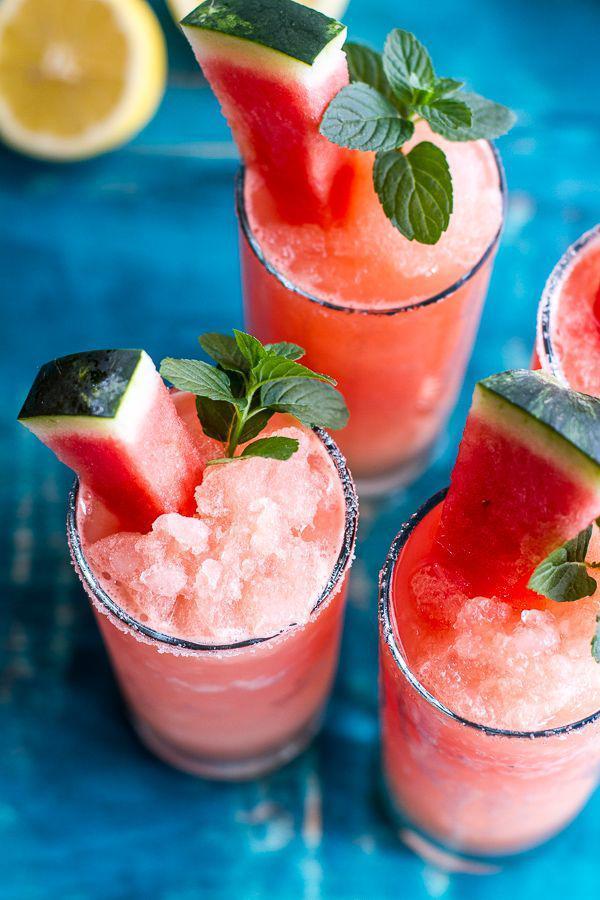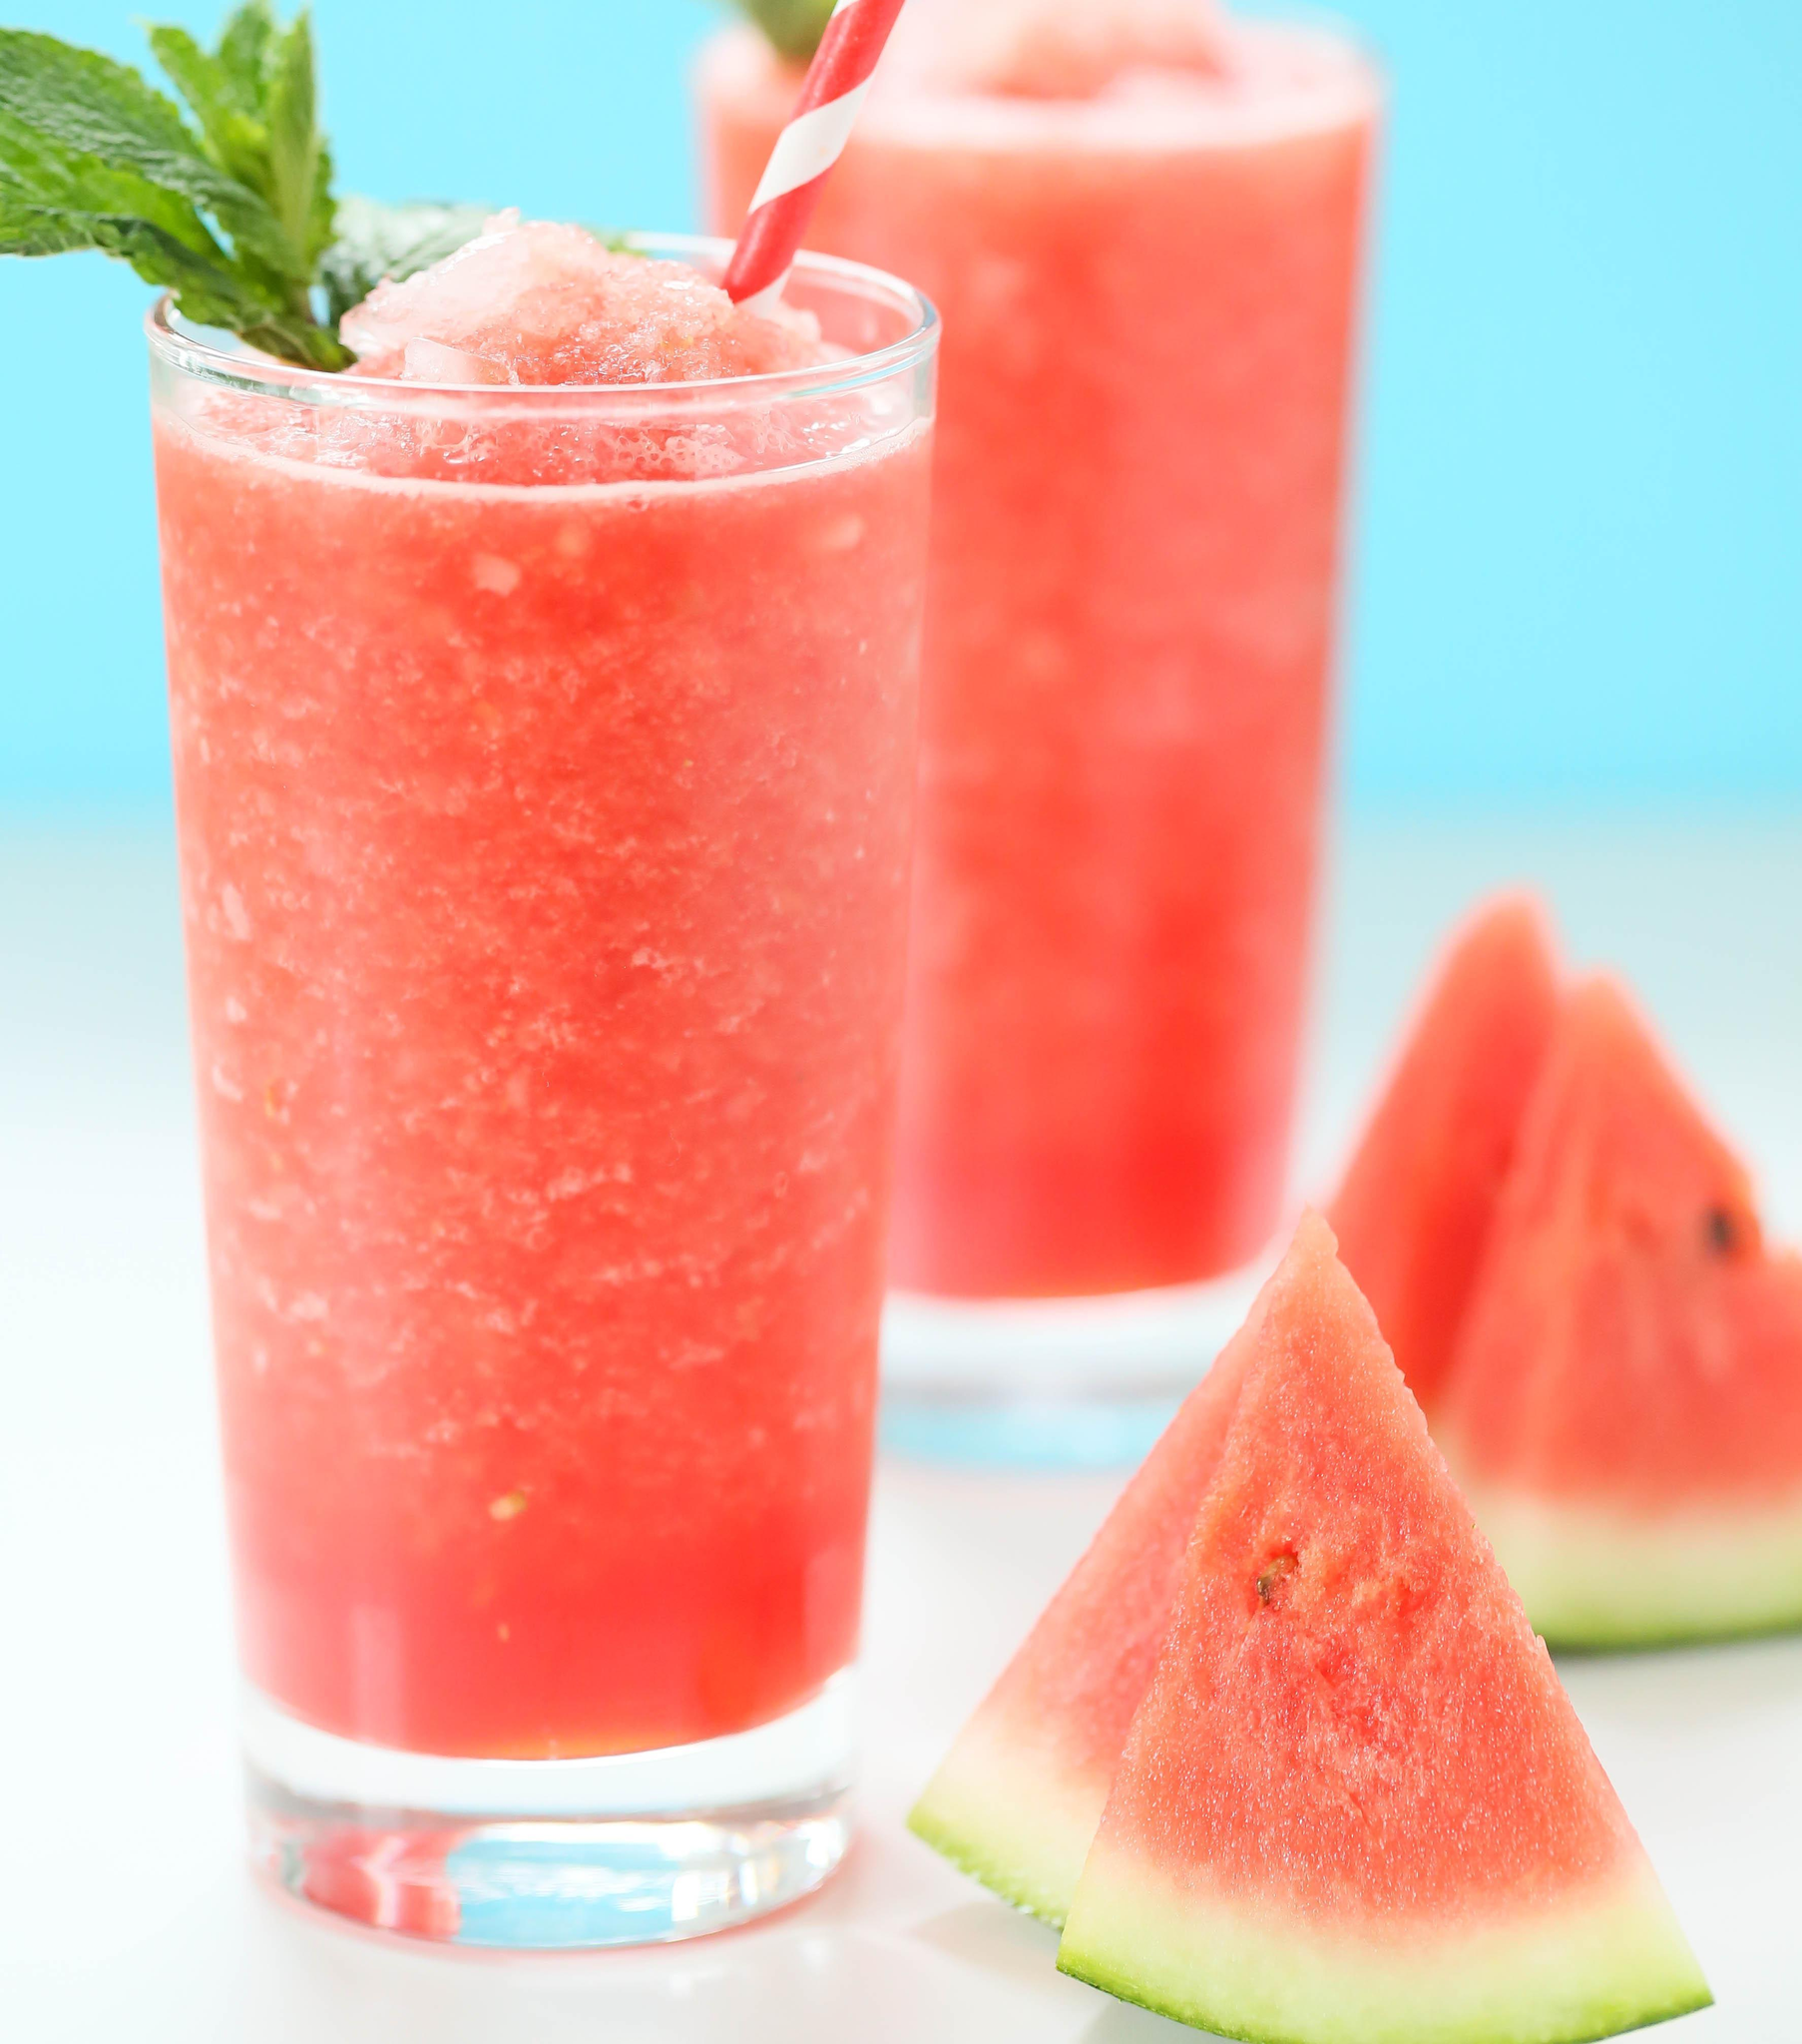The first image is the image on the left, the second image is the image on the right. Given the left and right images, does the statement "There are no more than 5 full drink glasses." hold true? Answer yes or no. No. The first image is the image on the left, the second image is the image on the right. Analyze the images presented: Is the assertion "Dessert drinks in one image are pink in tall glasses, and in the other are pink in short glasses." valid? Answer yes or no. Yes. 